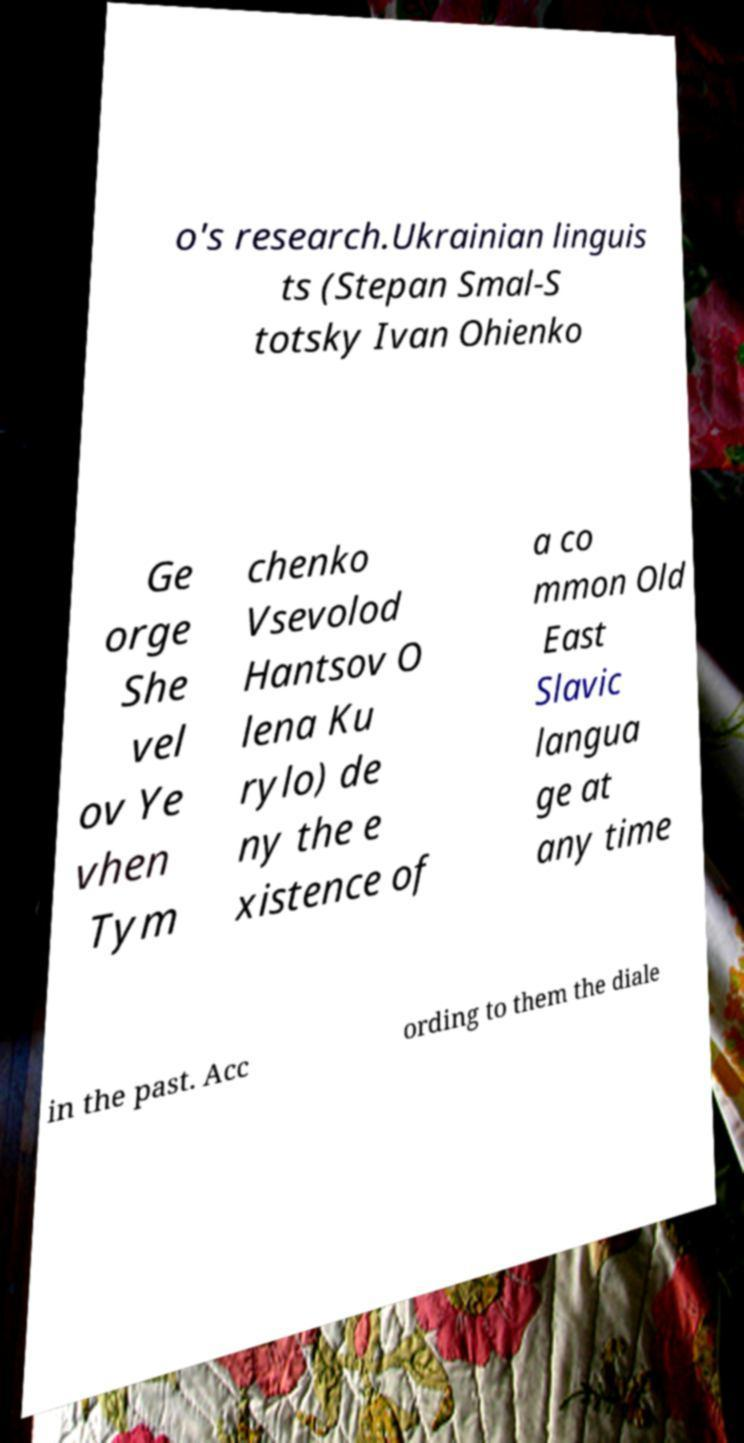Could you extract and type out the text from this image? o's research.Ukrainian linguis ts (Stepan Smal-S totsky Ivan Ohienko Ge orge She vel ov Ye vhen Tym chenko Vsevolod Hantsov O lena Ku rylo) de ny the e xistence of a co mmon Old East Slavic langua ge at any time in the past. Acc ording to them the diale 